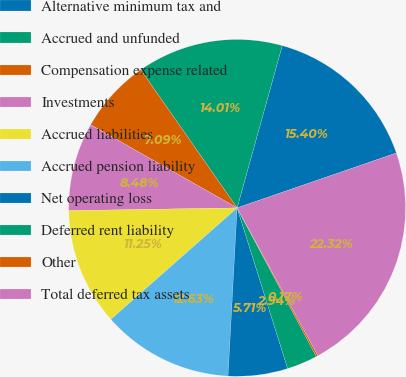Convert chart. <chart><loc_0><loc_0><loc_500><loc_500><pie_chart><fcel>Alternative minimum tax and<fcel>Accrued and unfunded<fcel>Compensation expense related<fcel>Investments<fcel>Accrued liabilities<fcel>Accrued pension liability<fcel>Net operating loss<fcel>Deferred rent liability<fcel>Other<fcel>Total deferred tax assets<nl><fcel>15.4%<fcel>14.01%<fcel>7.09%<fcel>8.48%<fcel>11.25%<fcel>12.63%<fcel>5.71%<fcel>2.94%<fcel>0.17%<fcel>22.32%<nl></chart> 